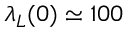Convert formula to latex. <formula><loc_0><loc_0><loc_500><loc_500>\lambda _ { L } ( 0 ) \simeq 1 0 0</formula> 